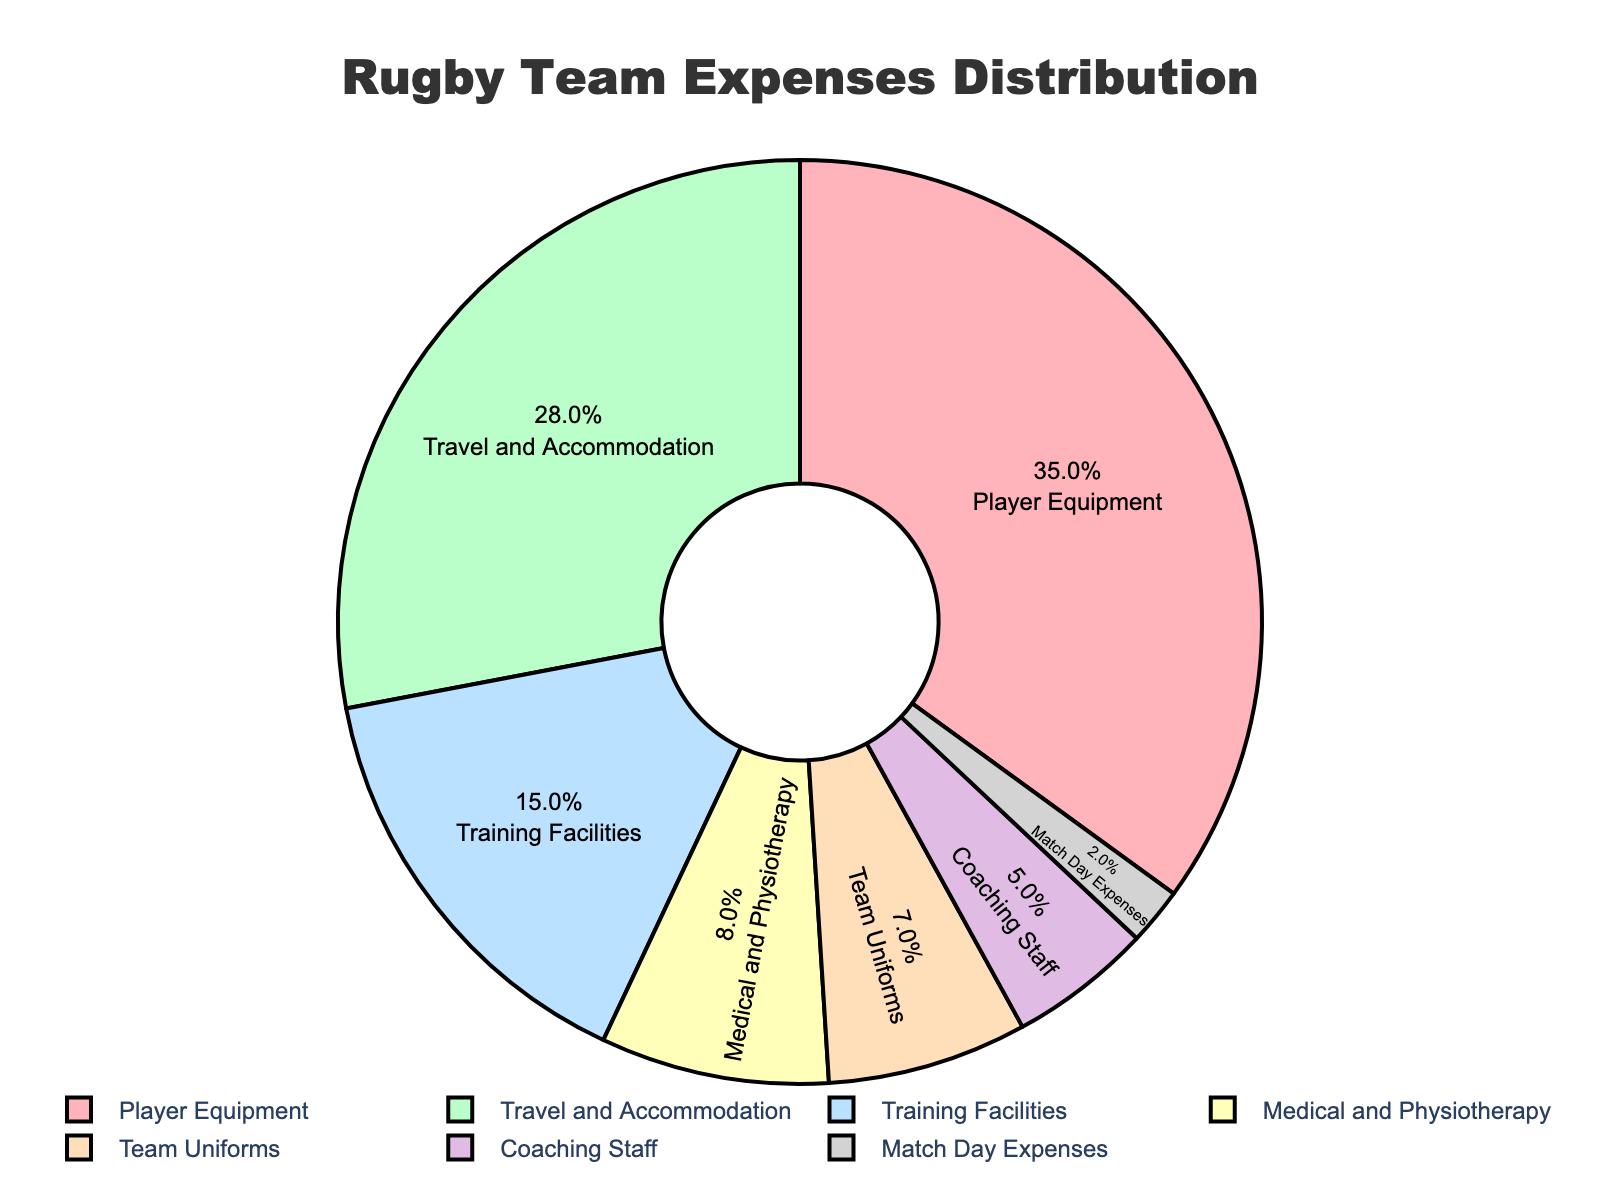Which category has the highest expense percentage? The pie chart shows that the Player Equipment category has the largest slice.
Answer: Player Equipment What is the combined expense percentage of Travel and Accommodation and Training Facilities? According to the pie chart, Travel and Accommodation is 28% and Training Facilities is 15%. Adding these percentages gives 28% + 15% = 43%.
Answer: 43% Which category has the least expense percentage, and how much is it? The pie chart indicates that Match Day Expenses has the smallest slice, representing 2% of the expenses.
Answer: Match Day Expenses, 2% How does the expense percentage for Medical and Physiotherapy compare with Team Uniforms? The pie chart shows that Medical and Physiotherapy is 8% while Team Uniforms is 7%, so Medical and Physiotherapy is 1% higher.
Answer: Medical and Physiotherapy is 1% higher What is the total percentage of expenses for categories related to physical aspects (Player Equipment, Medical and Physiotherapy)? From the pie chart, Player Equipment is 35% and Medical and Physiotherapy is 8%. Their total is 35% + 8% = 43%.
Answer: 43% By how much does the expense percentage for Training Facilities exceed that of Coaching Staff? The pie chart shows Training Facilities at 15% and Coaching Staff at 5%, thus the difference is 15% - 5% = 10%.
Answer: 10% What can you say about the expense allocation for Team Uniforms in relation to the total expenses? The pie chart indicates that Team Uniforms account for 7% of the total expenses. This means a significant but smaller part of the budget is allocated to uniforms.
Answer: 7% Which two categories have the closest expense percentages, and what are these percentages? The pie chart shows that Team Uniforms and Medical and Physiotherapy have the closest percentages with 7% and 8%, respectively, making a 1% difference.
Answer: Team Uniforms (7%), Medical and Physiotherapy (8%) How does the expense percentage for Player Equipment compare to the sum of Coaching Staff and Match Day Expenses? The pie chart indicates Player Equipment is 35%. Coaching Staff is 5% and Match Day Expenses is 2%, and their sum is 5% + 2% = 7%. Player Equipment is 35% - 7% = 28% higher.
Answer: Player Equipment is 28% higher What is the average expense percentage for all categories listed? There are 7 categories with the following percentages: 35%, 28%, 15%, 8%, 7%, 5%, 2%. Summing these percentages gives 100%. The average is 100% / 7 ≈ 14.3%.
Answer: ~14.3% 